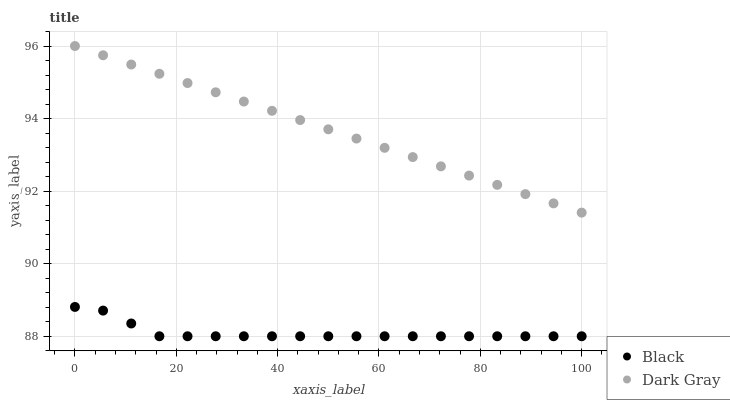Does Black have the minimum area under the curve?
Answer yes or no. Yes. Does Dark Gray have the maximum area under the curve?
Answer yes or no. Yes. Does Black have the maximum area under the curve?
Answer yes or no. No. Is Dark Gray the smoothest?
Answer yes or no. Yes. Is Black the roughest?
Answer yes or no. Yes. Is Black the smoothest?
Answer yes or no. No. Does Black have the lowest value?
Answer yes or no. Yes. Does Dark Gray have the highest value?
Answer yes or no. Yes. Does Black have the highest value?
Answer yes or no. No. Is Black less than Dark Gray?
Answer yes or no. Yes. Is Dark Gray greater than Black?
Answer yes or no. Yes. Does Black intersect Dark Gray?
Answer yes or no. No. 